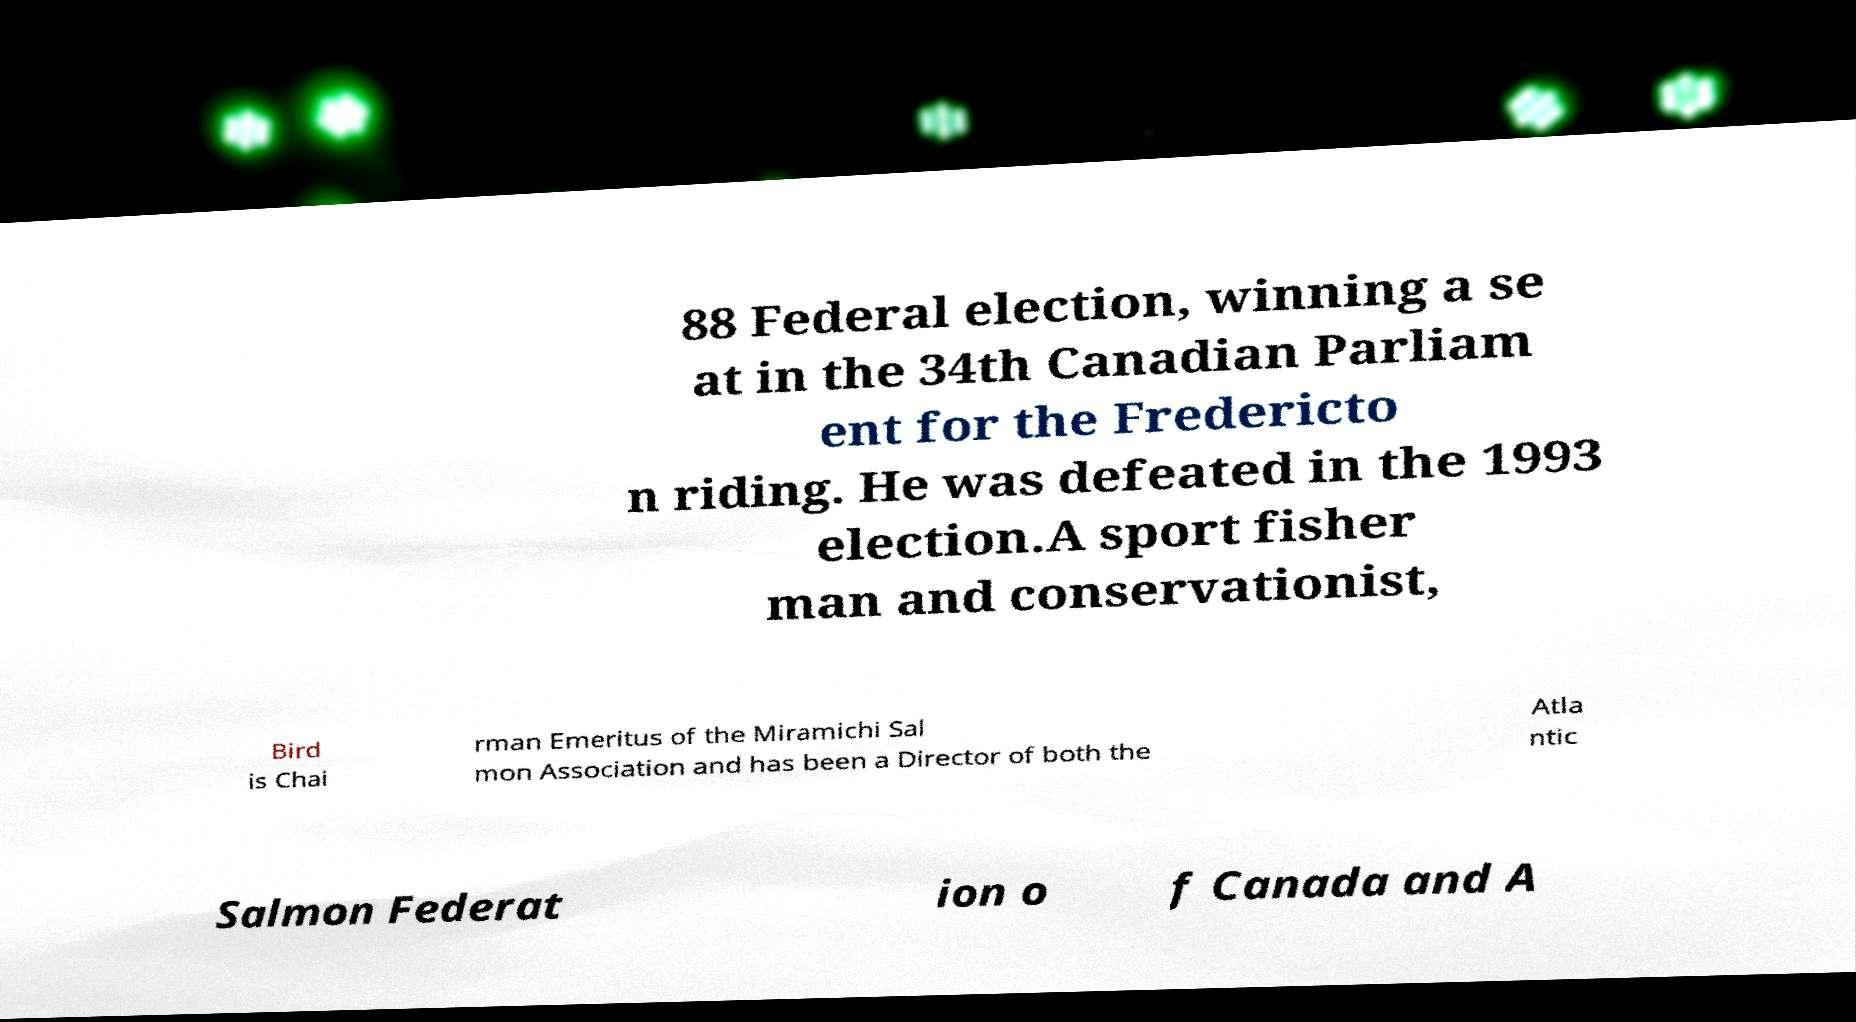Can you read and provide the text displayed in the image?This photo seems to have some interesting text. Can you extract and type it out for me? 88 Federal election, winning a se at in the 34th Canadian Parliam ent for the Fredericto n riding. He was defeated in the 1993 election.A sport fisher man and conservationist, Bird is Chai rman Emeritus of the Miramichi Sal mon Association and has been a Director of both the Atla ntic Salmon Federat ion o f Canada and A 